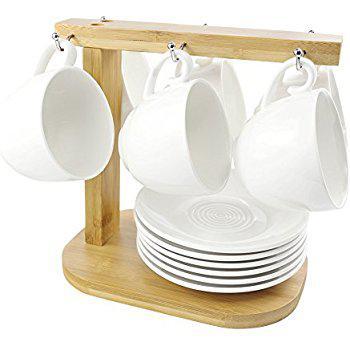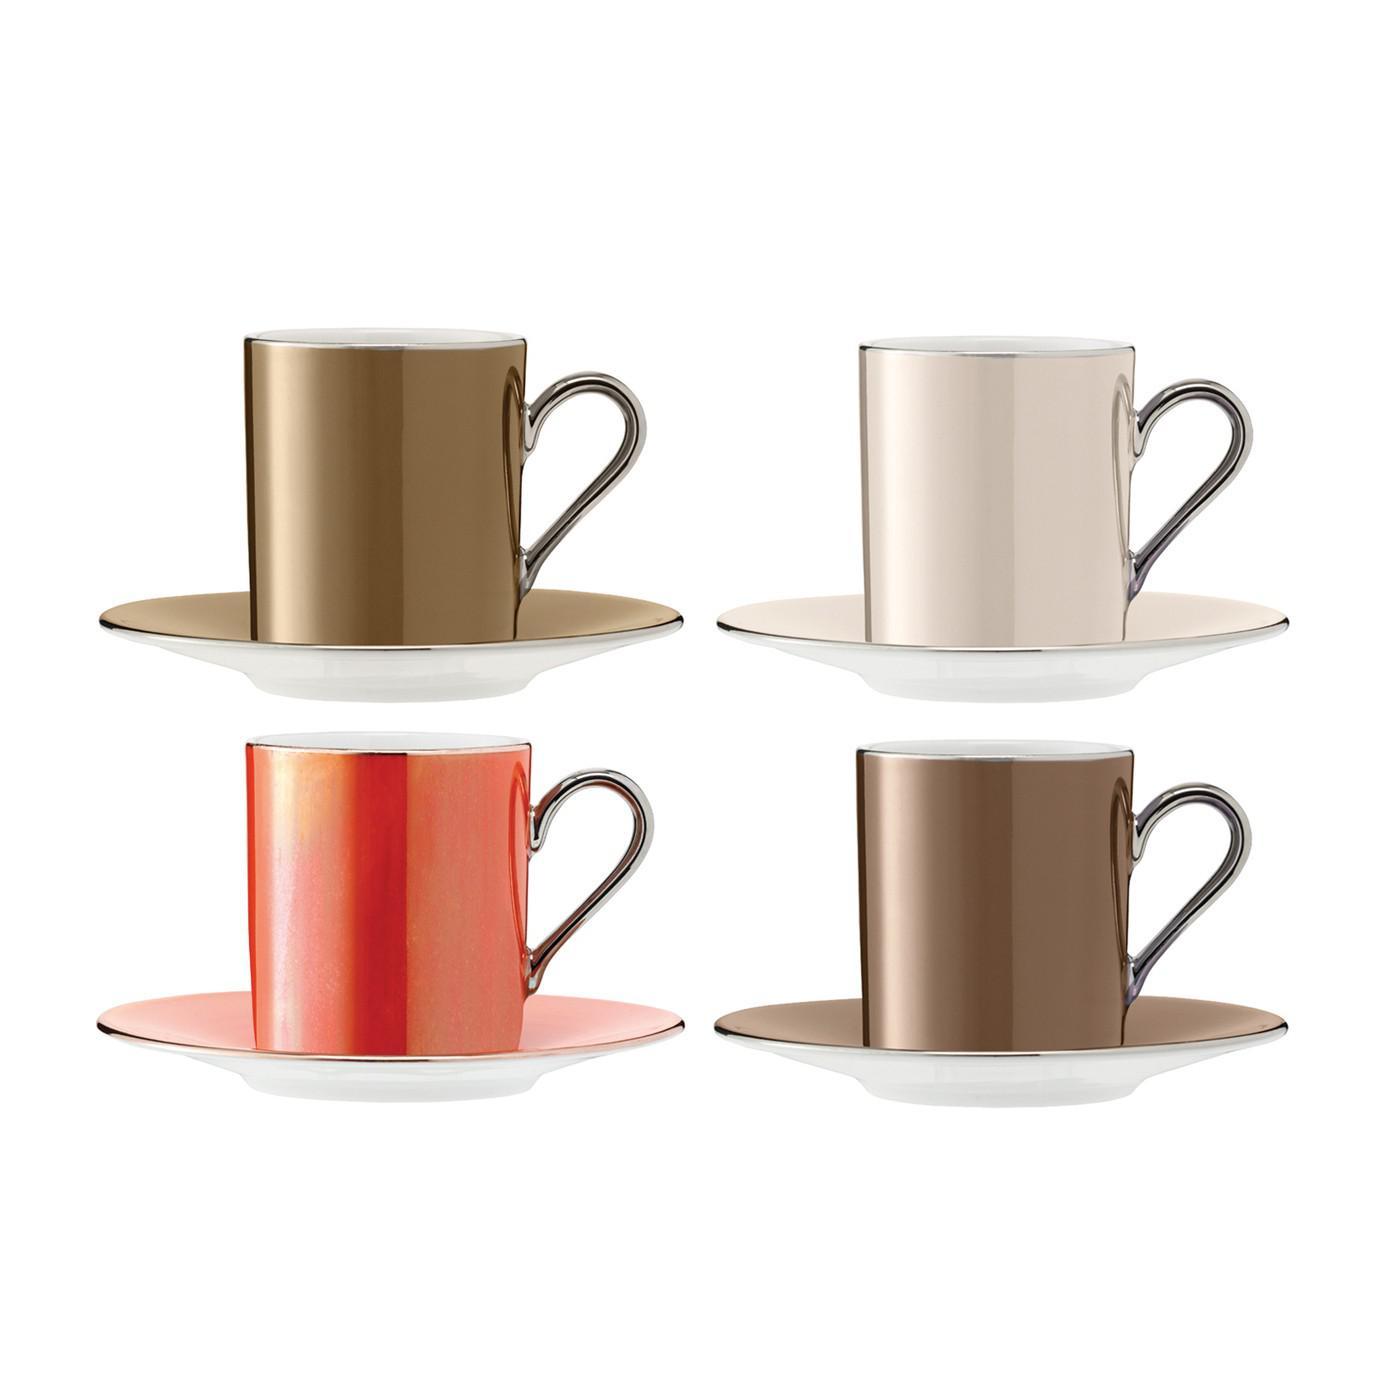The first image is the image on the left, the second image is the image on the right. Evaluate the accuracy of this statement regarding the images: "There is a teapot in one of the images.". Is it true? Answer yes or no. No. 